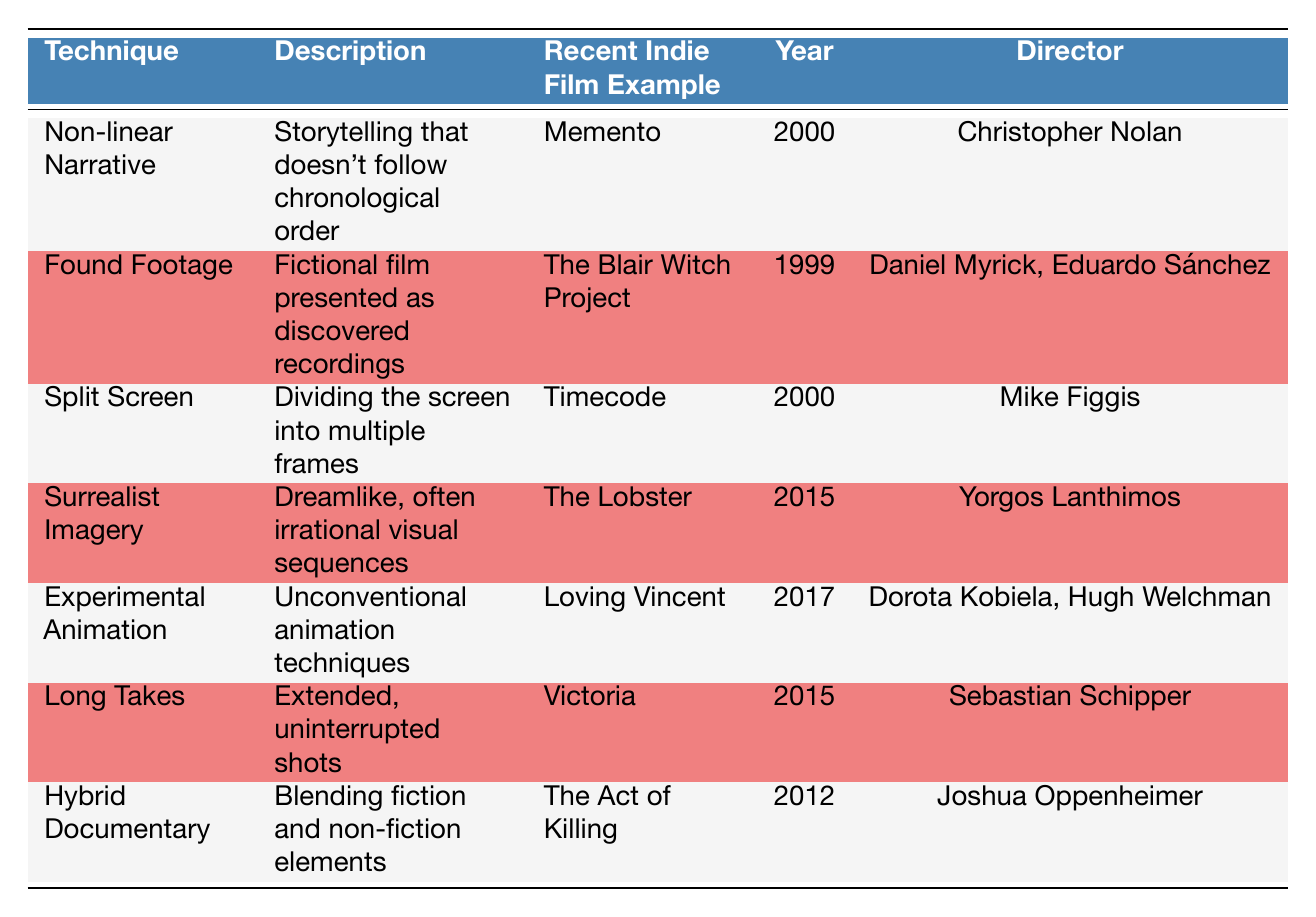What technique is used in the film "The Act of Killing"? The film "The Act of Killing" uses the technique of Hybrid Documentary. This can be found in the corresponding row under the column "Recent Indie Film Example."
Answer: Hybrid Documentary Which director is associated with the film "Loving Vincent"? The director associated with "Loving Vincent" is Dorota Kobiela and Hugh Welchman. This information can be found in the row of "Experimental Animation" under the "Director" column.
Answer: Dorota Kobiela, Hugh Welchman True or False: "Memento" uses Surrealist Imagery. This statement is false because "Memento" is listed under the "Non-linear Narrative" technique, while "Surrealist Imagery" is associated with "The Lobster."
Answer: False What year was "Victoria" released? "Victoria" was released in the year 2015. This information can be directly retrieved from the table in the row corresponding to "Long Takes."
Answer: 2015 Which two films are associated with the technique of Split Screen and what are their directors? The film "Timecode," which uses the Split Screen technique, was directed by Mike Figgis. This can be identified by checking the row for "Split Screen" in the table.
Answer: Timecode, Mike Figgis What is the average year of release for the films listed? To find the average year, first sum the given years: (2000 + 1999 + 2000 + 2015 + 2017 + 2015 + 2012 = 2001). There are 7 films, so the average year is 2001/7 = approximately 2001.
Answer: 2001 In which film was the Found Footage technique primarily utilized? The Found Footage technique was primarily utilized in "The Blair Witch Project." This can be identified by locating "Found Footage" in the corresponding row of the table.
Answer: The Blair Witch Project True or False: "Timecode" was directed by Sebastian Schipper. This statement is false as "Timecode" was directed by Mike Figgis. You can verify this by looking at the entry for "Split Screen" in the table.
Answer: False What type of visual sequences does Surrealist Imagery represent, and which film exemplifies this technique? Surrealist Imagery represents dreamlike, often irrational visual sequences and is exemplified by the film "The Lobster." This can be confirmed by checking the "Description" and "Recent Indie Film Example" columns for "Surrealist Imagery."
Answer: The Lobster 